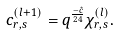Convert formula to latex. <formula><loc_0><loc_0><loc_500><loc_500>c _ { r , s } ^ { ( l + 1 ) } = q ^ { \frac { - \hat { c } } { 2 4 } } \chi _ { r , s } ^ { ( l ) } .</formula> 